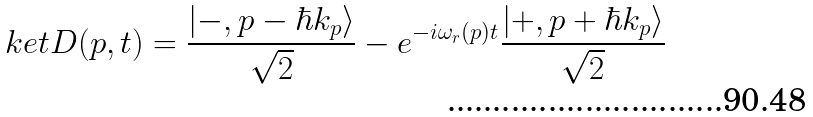<formula> <loc_0><loc_0><loc_500><loc_500>\ k e t { D ( p , t ) } = \frac { | - , p - \hbar { k } _ { p } \rangle } { \sqrt { 2 } } - e ^ { - i \omega _ { r } ( p ) t } \frac { | + , p + \hbar { k } _ { p } \rangle } { \sqrt { 2 } }</formula> 